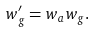<formula> <loc_0><loc_0><loc_500><loc_500>w _ { g } ^ { \prime } = w _ { a } w _ { g } .</formula> 